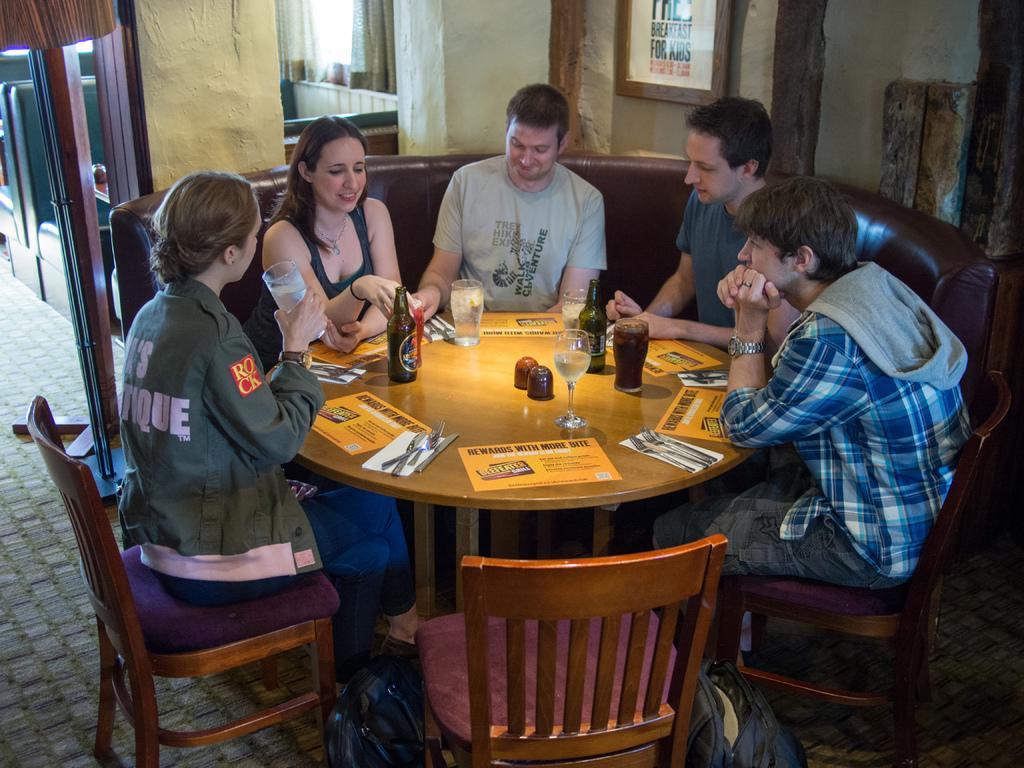In one or two sentences, can you explain what this image depicts? Here we can see some persons are sitting on the chairs. This is table. On the table there are bottles, glasses, spoons, and papers. This is floor. On the background there is a wall and this is frame. And there is a door. 